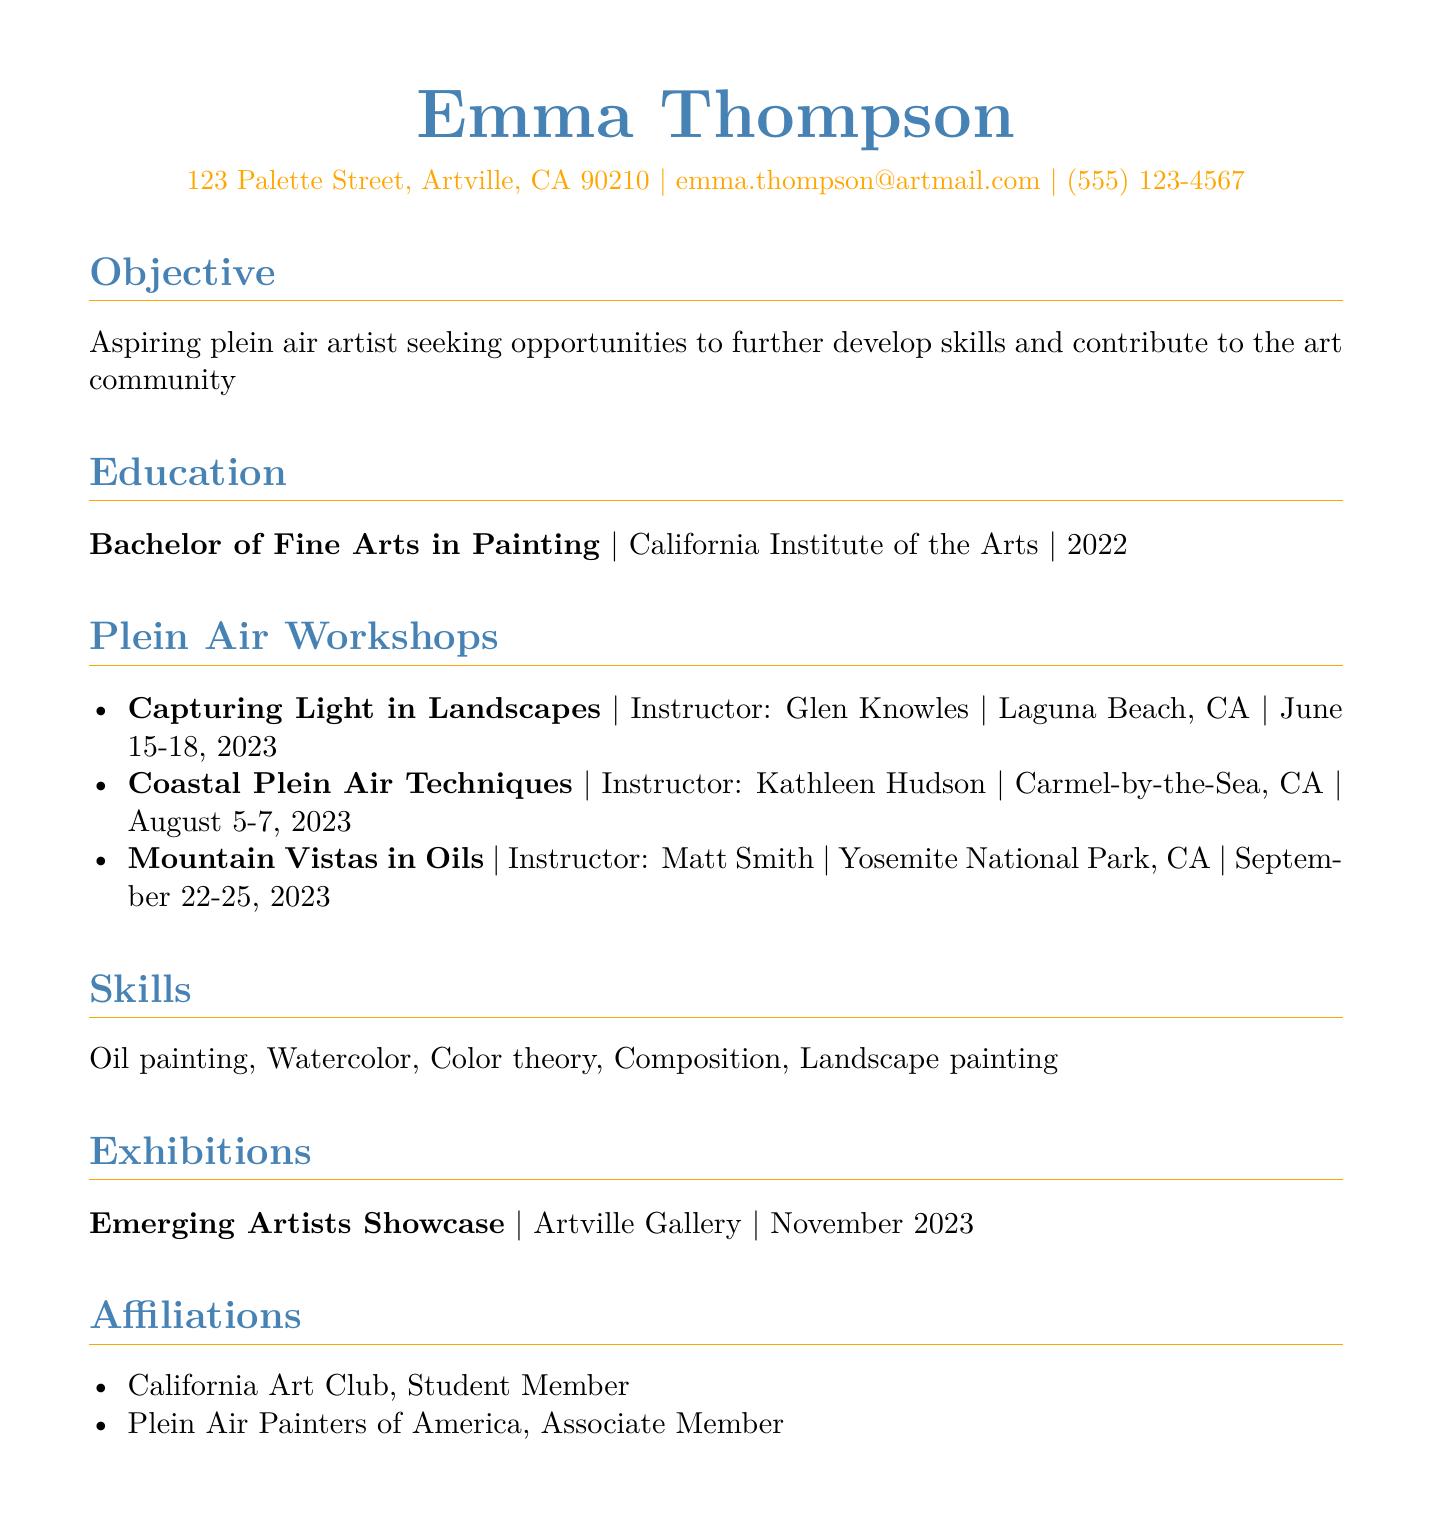what is the name of the artist? The name of the artist is listed at the top of the document.
Answer: Emma Thompson what is the degree earned by Emma Thompson? The degree is specified under the education section.
Answer: Bachelor of Fine Arts in Painting who is the instructor for the workshop titled "Capturing Light in Landscapes"? This information is detailed in the plein air workshops section.
Answer: Glen Knowles when did Emma Thompson attend the "Mountain Vistas in Oils" workshop? The date is provided next to the workshop title in the workshops section.
Answer: September 22-25, 2023 which location hosted the "Coastal Plein Air Techniques" workshop? The location is specified alongside the workshop title in the document.
Answer: Carmel-by-the-Sea, CA what skill related to painting is listed among Emma's abilities? This is found in the skills section of the document.
Answer: Oil painting how many plein air workshops has Emma Thompson attended? The number of workshops can be counted from the list in the document.
Answer: 3 which exhibition is mentioned in Emma’s CV? The title of the exhibition is given in the exhibitions section.
Answer: Emerging Artists Showcase what is the membership status in the California Art Club? The affiliation status is outlined in the affiliations section.
Answer: Student Member who was the instructor for the workshop held in Laguna Beach? This information can be found next to the relevant workshop title.
Answer: Glen Knowles 